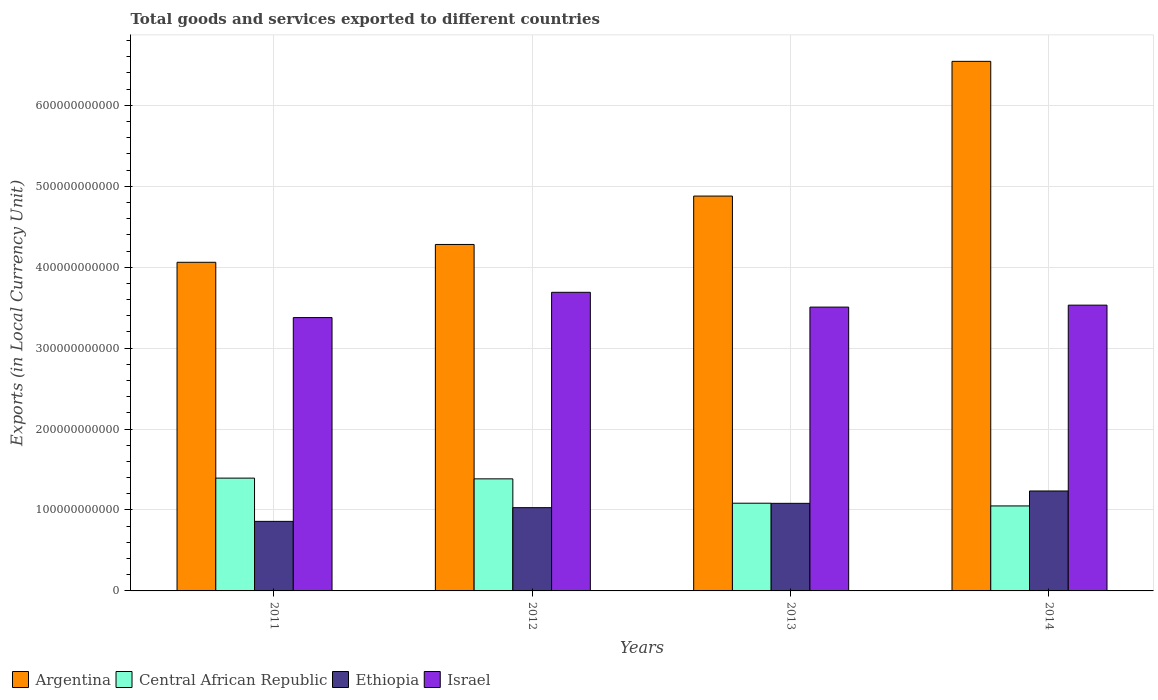How many different coloured bars are there?
Offer a terse response. 4. Are the number of bars per tick equal to the number of legend labels?
Your response must be concise. Yes. How many bars are there on the 2nd tick from the right?
Keep it short and to the point. 4. What is the Amount of goods and services exports in Ethiopia in 2011?
Make the answer very short. 8.60e+1. Across all years, what is the maximum Amount of goods and services exports in Argentina?
Ensure brevity in your answer.  6.54e+11. Across all years, what is the minimum Amount of goods and services exports in Argentina?
Keep it short and to the point. 4.06e+11. In which year was the Amount of goods and services exports in Ethiopia maximum?
Ensure brevity in your answer.  2014. In which year was the Amount of goods and services exports in Ethiopia minimum?
Ensure brevity in your answer.  2011. What is the total Amount of goods and services exports in Israel in the graph?
Your answer should be very brief. 1.41e+12. What is the difference between the Amount of goods and services exports in Israel in 2011 and that in 2012?
Ensure brevity in your answer.  -3.12e+1. What is the difference between the Amount of goods and services exports in Israel in 2014 and the Amount of goods and services exports in Central African Republic in 2012?
Provide a succinct answer. 2.15e+11. What is the average Amount of goods and services exports in Israel per year?
Provide a succinct answer. 3.53e+11. In the year 2014, what is the difference between the Amount of goods and services exports in Ethiopia and Amount of goods and services exports in Argentina?
Provide a succinct answer. -5.31e+11. What is the ratio of the Amount of goods and services exports in Argentina in 2011 to that in 2013?
Offer a terse response. 0.83. What is the difference between the highest and the second highest Amount of goods and services exports in Argentina?
Give a very brief answer. 1.66e+11. What is the difference between the highest and the lowest Amount of goods and services exports in Central African Republic?
Make the answer very short. 3.44e+1. In how many years, is the Amount of goods and services exports in Central African Republic greater than the average Amount of goods and services exports in Central African Republic taken over all years?
Your answer should be compact. 2. What does the 2nd bar from the left in 2013 represents?
Give a very brief answer. Central African Republic. How many bars are there?
Ensure brevity in your answer.  16. Are all the bars in the graph horizontal?
Make the answer very short. No. What is the difference between two consecutive major ticks on the Y-axis?
Offer a very short reply. 1.00e+11. Does the graph contain any zero values?
Offer a very short reply. No. Does the graph contain grids?
Make the answer very short. Yes. How many legend labels are there?
Provide a short and direct response. 4. What is the title of the graph?
Give a very brief answer. Total goods and services exported to different countries. Does "Sri Lanka" appear as one of the legend labels in the graph?
Provide a short and direct response. No. What is the label or title of the Y-axis?
Keep it short and to the point. Exports (in Local Currency Unit). What is the Exports (in Local Currency Unit) of Argentina in 2011?
Make the answer very short. 4.06e+11. What is the Exports (in Local Currency Unit) of Central African Republic in 2011?
Keep it short and to the point. 1.39e+11. What is the Exports (in Local Currency Unit) of Ethiopia in 2011?
Ensure brevity in your answer.  8.60e+1. What is the Exports (in Local Currency Unit) of Israel in 2011?
Keep it short and to the point. 3.38e+11. What is the Exports (in Local Currency Unit) of Argentina in 2012?
Your answer should be very brief. 4.28e+11. What is the Exports (in Local Currency Unit) of Central African Republic in 2012?
Ensure brevity in your answer.  1.38e+11. What is the Exports (in Local Currency Unit) of Ethiopia in 2012?
Offer a very short reply. 1.03e+11. What is the Exports (in Local Currency Unit) of Israel in 2012?
Provide a succinct answer. 3.69e+11. What is the Exports (in Local Currency Unit) of Argentina in 2013?
Ensure brevity in your answer.  4.88e+11. What is the Exports (in Local Currency Unit) in Central African Republic in 2013?
Offer a terse response. 1.08e+11. What is the Exports (in Local Currency Unit) in Ethiopia in 2013?
Keep it short and to the point. 1.08e+11. What is the Exports (in Local Currency Unit) of Israel in 2013?
Make the answer very short. 3.51e+11. What is the Exports (in Local Currency Unit) of Argentina in 2014?
Make the answer very short. 6.54e+11. What is the Exports (in Local Currency Unit) of Central African Republic in 2014?
Give a very brief answer. 1.05e+11. What is the Exports (in Local Currency Unit) of Ethiopia in 2014?
Offer a very short reply. 1.23e+11. What is the Exports (in Local Currency Unit) of Israel in 2014?
Provide a short and direct response. 3.53e+11. Across all years, what is the maximum Exports (in Local Currency Unit) in Argentina?
Ensure brevity in your answer.  6.54e+11. Across all years, what is the maximum Exports (in Local Currency Unit) of Central African Republic?
Offer a terse response. 1.39e+11. Across all years, what is the maximum Exports (in Local Currency Unit) of Ethiopia?
Your answer should be compact. 1.23e+11. Across all years, what is the maximum Exports (in Local Currency Unit) in Israel?
Your answer should be compact. 3.69e+11. Across all years, what is the minimum Exports (in Local Currency Unit) in Argentina?
Provide a short and direct response. 4.06e+11. Across all years, what is the minimum Exports (in Local Currency Unit) in Central African Republic?
Offer a terse response. 1.05e+11. Across all years, what is the minimum Exports (in Local Currency Unit) in Ethiopia?
Your answer should be compact. 8.60e+1. Across all years, what is the minimum Exports (in Local Currency Unit) in Israel?
Provide a short and direct response. 3.38e+11. What is the total Exports (in Local Currency Unit) in Argentina in the graph?
Provide a succinct answer. 1.98e+12. What is the total Exports (in Local Currency Unit) in Central African Republic in the graph?
Offer a terse response. 4.91e+11. What is the total Exports (in Local Currency Unit) of Ethiopia in the graph?
Offer a terse response. 4.21e+11. What is the total Exports (in Local Currency Unit) of Israel in the graph?
Give a very brief answer. 1.41e+12. What is the difference between the Exports (in Local Currency Unit) in Argentina in 2011 and that in 2012?
Give a very brief answer. -2.20e+1. What is the difference between the Exports (in Local Currency Unit) of Central African Republic in 2011 and that in 2012?
Make the answer very short. 9.10e+08. What is the difference between the Exports (in Local Currency Unit) of Ethiopia in 2011 and that in 2012?
Offer a terse response. -1.69e+1. What is the difference between the Exports (in Local Currency Unit) in Israel in 2011 and that in 2012?
Your response must be concise. -3.12e+1. What is the difference between the Exports (in Local Currency Unit) in Argentina in 2011 and that in 2013?
Give a very brief answer. -8.18e+1. What is the difference between the Exports (in Local Currency Unit) of Central African Republic in 2011 and that in 2013?
Your response must be concise. 3.10e+1. What is the difference between the Exports (in Local Currency Unit) of Ethiopia in 2011 and that in 2013?
Offer a terse response. -2.23e+1. What is the difference between the Exports (in Local Currency Unit) in Israel in 2011 and that in 2013?
Your response must be concise. -1.29e+1. What is the difference between the Exports (in Local Currency Unit) of Argentina in 2011 and that in 2014?
Your response must be concise. -2.48e+11. What is the difference between the Exports (in Local Currency Unit) of Central African Republic in 2011 and that in 2014?
Your response must be concise. 3.44e+1. What is the difference between the Exports (in Local Currency Unit) of Ethiopia in 2011 and that in 2014?
Offer a very short reply. -3.75e+1. What is the difference between the Exports (in Local Currency Unit) of Israel in 2011 and that in 2014?
Ensure brevity in your answer.  -1.54e+1. What is the difference between the Exports (in Local Currency Unit) of Argentina in 2012 and that in 2013?
Provide a short and direct response. -5.98e+1. What is the difference between the Exports (in Local Currency Unit) in Central African Republic in 2012 and that in 2013?
Ensure brevity in your answer.  3.01e+1. What is the difference between the Exports (in Local Currency Unit) in Ethiopia in 2012 and that in 2013?
Give a very brief answer. -5.34e+09. What is the difference between the Exports (in Local Currency Unit) in Israel in 2012 and that in 2013?
Give a very brief answer. 1.83e+1. What is the difference between the Exports (in Local Currency Unit) in Argentina in 2012 and that in 2014?
Provide a succinct answer. -2.26e+11. What is the difference between the Exports (in Local Currency Unit) in Central African Republic in 2012 and that in 2014?
Your answer should be very brief. 3.35e+1. What is the difference between the Exports (in Local Currency Unit) in Ethiopia in 2012 and that in 2014?
Provide a short and direct response. -2.06e+1. What is the difference between the Exports (in Local Currency Unit) in Israel in 2012 and that in 2014?
Ensure brevity in your answer.  1.59e+1. What is the difference between the Exports (in Local Currency Unit) in Argentina in 2013 and that in 2014?
Provide a short and direct response. -1.66e+11. What is the difference between the Exports (in Local Currency Unit) of Central African Republic in 2013 and that in 2014?
Your answer should be very brief. 3.37e+09. What is the difference between the Exports (in Local Currency Unit) in Ethiopia in 2013 and that in 2014?
Ensure brevity in your answer.  -1.53e+1. What is the difference between the Exports (in Local Currency Unit) of Israel in 2013 and that in 2014?
Ensure brevity in your answer.  -2.42e+09. What is the difference between the Exports (in Local Currency Unit) of Argentina in 2011 and the Exports (in Local Currency Unit) of Central African Republic in 2012?
Your response must be concise. 2.68e+11. What is the difference between the Exports (in Local Currency Unit) in Argentina in 2011 and the Exports (in Local Currency Unit) in Ethiopia in 2012?
Your answer should be very brief. 3.03e+11. What is the difference between the Exports (in Local Currency Unit) in Argentina in 2011 and the Exports (in Local Currency Unit) in Israel in 2012?
Offer a very short reply. 3.71e+1. What is the difference between the Exports (in Local Currency Unit) in Central African Republic in 2011 and the Exports (in Local Currency Unit) in Ethiopia in 2012?
Provide a short and direct response. 3.65e+1. What is the difference between the Exports (in Local Currency Unit) in Central African Republic in 2011 and the Exports (in Local Currency Unit) in Israel in 2012?
Provide a succinct answer. -2.30e+11. What is the difference between the Exports (in Local Currency Unit) in Ethiopia in 2011 and the Exports (in Local Currency Unit) in Israel in 2012?
Your answer should be very brief. -2.83e+11. What is the difference between the Exports (in Local Currency Unit) of Argentina in 2011 and the Exports (in Local Currency Unit) of Central African Republic in 2013?
Offer a terse response. 2.98e+11. What is the difference between the Exports (in Local Currency Unit) of Argentina in 2011 and the Exports (in Local Currency Unit) of Ethiopia in 2013?
Keep it short and to the point. 2.98e+11. What is the difference between the Exports (in Local Currency Unit) of Argentina in 2011 and the Exports (in Local Currency Unit) of Israel in 2013?
Your response must be concise. 5.54e+1. What is the difference between the Exports (in Local Currency Unit) of Central African Republic in 2011 and the Exports (in Local Currency Unit) of Ethiopia in 2013?
Your answer should be very brief. 3.12e+1. What is the difference between the Exports (in Local Currency Unit) in Central African Republic in 2011 and the Exports (in Local Currency Unit) in Israel in 2013?
Provide a succinct answer. -2.11e+11. What is the difference between the Exports (in Local Currency Unit) of Ethiopia in 2011 and the Exports (in Local Currency Unit) of Israel in 2013?
Provide a short and direct response. -2.65e+11. What is the difference between the Exports (in Local Currency Unit) in Argentina in 2011 and the Exports (in Local Currency Unit) in Central African Republic in 2014?
Your answer should be compact. 3.01e+11. What is the difference between the Exports (in Local Currency Unit) in Argentina in 2011 and the Exports (in Local Currency Unit) in Ethiopia in 2014?
Offer a very short reply. 2.83e+11. What is the difference between the Exports (in Local Currency Unit) of Argentina in 2011 and the Exports (in Local Currency Unit) of Israel in 2014?
Offer a very short reply. 5.30e+1. What is the difference between the Exports (in Local Currency Unit) of Central African Republic in 2011 and the Exports (in Local Currency Unit) of Ethiopia in 2014?
Offer a very short reply. 1.59e+1. What is the difference between the Exports (in Local Currency Unit) of Central African Republic in 2011 and the Exports (in Local Currency Unit) of Israel in 2014?
Offer a very short reply. -2.14e+11. What is the difference between the Exports (in Local Currency Unit) in Ethiopia in 2011 and the Exports (in Local Currency Unit) in Israel in 2014?
Provide a succinct answer. -2.67e+11. What is the difference between the Exports (in Local Currency Unit) of Argentina in 2012 and the Exports (in Local Currency Unit) of Central African Republic in 2013?
Offer a terse response. 3.20e+11. What is the difference between the Exports (in Local Currency Unit) of Argentina in 2012 and the Exports (in Local Currency Unit) of Ethiopia in 2013?
Your answer should be very brief. 3.20e+11. What is the difference between the Exports (in Local Currency Unit) of Argentina in 2012 and the Exports (in Local Currency Unit) of Israel in 2013?
Your answer should be very brief. 7.74e+1. What is the difference between the Exports (in Local Currency Unit) of Central African Republic in 2012 and the Exports (in Local Currency Unit) of Ethiopia in 2013?
Keep it short and to the point. 3.03e+1. What is the difference between the Exports (in Local Currency Unit) of Central African Republic in 2012 and the Exports (in Local Currency Unit) of Israel in 2013?
Your answer should be compact. -2.12e+11. What is the difference between the Exports (in Local Currency Unit) of Ethiopia in 2012 and the Exports (in Local Currency Unit) of Israel in 2013?
Your answer should be compact. -2.48e+11. What is the difference between the Exports (in Local Currency Unit) in Argentina in 2012 and the Exports (in Local Currency Unit) in Central African Republic in 2014?
Keep it short and to the point. 3.23e+11. What is the difference between the Exports (in Local Currency Unit) of Argentina in 2012 and the Exports (in Local Currency Unit) of Ethiopia in 2014?
Offer a very short reply. 3.05e+11. What is the difference between the Exports (in Local Currency Unit) in Argentina in 2012 and the Exports (in Local Currency Unit) in Israel in 2014?
Your answer should be very brief. 7.50e+1. What is the difference between the Exports (in Local Currency Unit) in Central African Republic in 2012 and the Exports (in Local Currency Unit) in Ethiopia in 2014?
Keep it short and to the point. 1.50e+1. What is the difference between the Exports (in Local Currency Unit) in Central African Republic in 2012 and the Exports (in Local Currency Unit) in Israel in 2014?
Give a very brief answer. -2.15e+11. What is the difference between the Exports (in Local Currency Unit) of Ethiopia in 2012 and the Exports (in Local Currency Unit) of Israel in 2014?
Provide a short and direct response. -2.50e+11. What is the difference between the Exports (in Local Currency Unit) in Argentina in 2013 and the Exports (in Local Currency Unit) in Central African Republic in 2014?
Provide a short and direct response. 3.83e+11. What is the difference between the Exports (in Local Currency Unit) of Argentina in 2013 and the Exports (in Local Currency Unit) of Ethiopia in 2014?
Your response must be concise. 3.64e+11. What is the difference between the Exports (in Local Currency Unit) of Argentina in 2013 and the Exports (in Local Currency Unit) of Israel in 2014?
Your answer should be compact. 1.35e+11. What is the difference between the Exports (in Local Currency Unit) of Central African Republic in 2013 and the Exports (in Local Currency Unit) of Ethiopia in 2014?
Your answer should be compact. -1.51e+1. What is the difference between the Exports (in Local Currency Unit) in Central African Republic in 2013 and the Exports (in Local Currency Unit) in Israel in 2014?
Provide a short and direct response. -2.45e+11. What is the difference between the Exports (in Local Currency Unit) in Ethiopia in 2013 and the Exports (in Local Currency Unit) in Israel in 2014?
Offer a very short reply. -2.45e+11. What is the average Exports (in Local Currency Unit) in Argentina per year?
Give a very brief answer. 4.94e+11. What is the average Exports (in Local Currency Unit) in Central African Republic per year?
Provide a succinct answer. 1.23e+11. What is the average Exports (in Local Currency Unit) of Ethiopia per year?
Provide a short and direct response. 1.05e+11. What is the average Exports (in Local Currency Unit) of Israel per year?
Offer a terse response. 3.53e+11. In the year 2011, what is the difference between the Exports (in Local Currency Unit) in Argentina and Exports (in Local Currency Unit) in Central African Republic?
Your answer should be compact. 2.67e+11. In the year 2011, what is the difference between the Exports (in Local Currency Unit) in Argentina and Exports (in Local Currency Unit) in Ethiopia?
Ensure brevity in your answer.  3.20e+11. In the year 2011, what is the difference between the Exports (in Local Currency Unit) in Argentina and Exports (in Local Currency Unit) in Israel?
Keep it short and to the point. 6.83e+1. In the year 2011, what is the difference between the Exports (in Local Currency Unit) in Central African Republic and Exports (in Local Currency Unit) in Ethiopia?
Your response must be concise. 5.34e+1. In the year 2011, what is the difference between the Exports (in Local Currency Unit) in Central African Republic and Exports (in Local Currency Unit) in Israel?
Offer a terse response. -1.98e+11. In the year 2011, what is the difference between the Exports (in Local Currency Unit) in Ethiopia and Exports (in Local Currency Unit) in Israel?
Your answer should be compact. -2.52e+11. In the year 2012, what is the difference between the Exports (in Local Currency Unit) of Argentina and Exports (in Local Currency Unit) of Central African Republic?
Your answer should be compact. 2.90e+11. In the year 2012, what is the difference between the Exports (in Local Currency Unit) of Argentina and Exports (in Local Currency Unit) of Ethiopia?
Provide a succinct answer. 3.25e+11. In the year 2012, what is the difference between the Exports (in Local Currency Unit) in Argentina and Exports (in Local Currency Unit) in Israel?
Provide a succinct answer. 5.91e+1. In the year 2012, what is the difference between the Exports (in Local Currency Unit) of Central African Republic and Exports (in Local Currency Unit) of Ethiopia?
Your answer should be very brief. 3.56e+1. In the year 2012, what is the difference between the Exports (in Local Currency Unit) of Central African Republic and Exports (in Local Currency Unit) of Israel?
Provide a succinct answer. -2.31e+11. In the year 2012, what is the difference between the Exports (in Local Currency Unit) in Ethiopia and Exports (in Local Currency Unit) in Israel?
Your response must be concise. -2.66e+11. In the year 2013, what is the difference between the Exports (in Local Currency Unit) in Argentina and Exports (in Local Currency Unit) in Central African Republic?
Your answer should be compact. 3.80e+11. In the year 2013, what is the difference between the Exports (in Local Currency Unit) in Argentina and Exports (in Local Currency Unit) in Ethiopia?
Your answer should be compact. 3.80e+11. In the year 2013, what is the difference between the Exports (in Local Currency Unit) in Argentina and Exports (in Local Currency Unit) in Israel?
Offer a very short reply. 1.37e+11. In the year 2013, what is the difference between the Exports (in Local Currency Unit) of Central African Republic and Exports (in Local Currency Unit) of Ethiopia?
Ensure brevity in your answer.  1.56e+08. In the year 2013, what is the difference between the Exports (in Local Currency Unit) in Central African Republic and Exports (in Local Currency Unit) in Israel?
Your response must be concise. -2.42e+11. In the year 2013, what is the difference between the Exports (in Local Currency Unit) of Ethiopia and Exports (in Local Currency Unit) of Israel?
Your answer should be compact. -2.42e+11. In the year 2014, what is the difference between the Exports (in Local Currency Unit) in Argentina and Exports (in Local Currency Unit) in Central African Republic?
Make the answer very short. 5.49e+11. In the year 2014, what is the difference between the Exports (in Local Currency Unit) of Argentina and Exports (in Local Currency Unit) of Ethiopia?
Keep it short and to the point. 5.31e+11. In the year 2014, what is the difference between the Exports (in Local Currency Unit) in Argentina and Exports (in Local Currency Unit) in Israel?
Your answer should be compact. 3.01e+11. In the year 2014, what is the difference between the Exports (in Local Currency Unit) in Central African Republic and Exports (in Local Currency Unit) in Ethiopia?
Provide a short and direct response. -1.85e+1. In the year 2014, what is the difference between the Exports (in Local Currency Unit) in Central African Republic and Exports (in Local Currency Unit) in Israel?
Give a very brief answer. -2.48e+11. In the year 2014, what is the difference between the Exports (in Local Currency Unit) in Ethiopia and Exports (in Local Currency Unit) in Israel?
Your answer should be very brief. -2.30e+11. What is the ratio of the Exports (in Local Currency Unit) in Argentina in 2011 to that in 2012?
Provide a succinct answer. 0.95. What is the ratio of the Exports (in Local Currency Unit) of Central African Republic in 2011 to that in 2012?
Provide a succinct answer. 1.01. What is the ratio of the Exports (in Local Currency Unit) of Ethiopia in 2011 to that in 2012?
Make the answer very short. 0.84. What is the ratio of the Exports (in Local Currency Unit) of Israel in 2011 to that in 2012?
Your response must be concise. 0.92. What is the ratio of the Exports (in Local Currency Unit) of Argentina in 2011 to that in 2013?
Provide a short and direct response. 0.83. What is the ratio of the Exports (in Local Currency Unit) of Central African Republic in 2011 to that in 2013?
Your answer should be very brief. 1.29. What is the ratio of the Exports (in Local Currency Unit) of Ethiopia in 2011 to that in 2013?
Offer a very short reply. 0.79. What is the ratio of the Exports (in Local Currency Unit) of Israel in 2011 to that in 2013?
Your answer should be very brief. 0.96. What is the ratio of the Exports (in Local Currency Unit) in Argentina in 2011 to that in 2014?
Keep it short and to the point. 0.62. What is the ratio of the Exports (in Local Currency Unit) in Central African Republic in 2011 to that in 2014?
Offer a very short reply. 1.33. What is the ratio of the Exports (in Local Currency Unit) in Ethiopia in 2011 to that in 2014?
Offer a terse response. 0.7. What is the ratio of the Exports (in Local Currency Unit) in Israel in 2011 to that in 2014?
Your response must be concise. 0.96. What is the ratio of the Exports (in Local Currency Unit) of Argentina in 2012 to that in 2013?
Your response must be concise. 0.88. What is the ratio of the Exports (in Local Currency Unit) of Central African Republic in 2012 to that in 2013?
Keep it short and to the point. 1.28. What is the ratio of the Exports (in Local Currency Unit) in Ethiopia in 2012 to that in 2013?
Provide a succinct answer. 0.95. What is the ratio of the Exports (in Local Currency Unit) of Israel in 2012 to that in 2013?
Ensure brevity in your answer.  1.05. What is the ratio of the Exports (in Local Currency Unit) in Argentina in 2012 to that in 2014?
Your response must be concise. 0.65. What is the ratio of the Exports (in Local Currency Unit) in Central African Republic in 2012 to that in 2014?
Provide a succinct answer. 1.32. What is the ratio of the Exports (in Local Currency Unit) in Ethiopia in 2012 to that in 2014?
Your answer should be very brief. 0.83. What is the ratio of the Exports (in Local Currency Unit) in Israel in 2012 to that in 2014?
Ensure brevity in your answer.  1.04. What is the ratio of the Exports (in Local Currency Unit) of Argentina in 2013 to that in 2014?
Your answer should be compact. 0.75. What is the ratio of the Exports (in Local Currency Unit) in Central African Republic in 2013 to that in 2014?
Offer a very short reply. 1.03. What is the ratio of the Exports (in Local Currency Unit) of Ethiopia in 2013 to that in 2014?
Keep it short and to the point. 0.88. What is the difference between the highest and the second highest Exports (in Local Currency Unit) of Argentina?
Provide a succinct answer. 1.66e+11. What is the difference between the highest and the second highest Exports (in Local Currency Unit) of Central African Republic?
Your response must be concise. 9.10e+08. What is the difference between the highest and the second highest Exports (in Local Currency Unit) of Ethiopia?
Your response must be concise. 1.53e+1. What is the difference between the highest and the second highest Exports (in Local Currency Unit) in Israel?
Provide a succinct answer. 1.59e+1. What is the difference between the highest and the lowest Exports (in Local Currency Unit) in Argentina?
Give a very brief answer. 2.48e+11. What is the difference between the highest and the lowest Exports (in Local Currency Unit) in Central African Republic?
Your answer should be compact. 3.44e+1. What is the difference between the highest and the lowest Exports (in Local Currency Unit) in Ethiopia?
Your answer should be compact. 3.75e+1. What is the difference between the highest and the lowest Exports (in Local Currency Unit) of Israel?
Offer a terse response. 3.12e+1. 